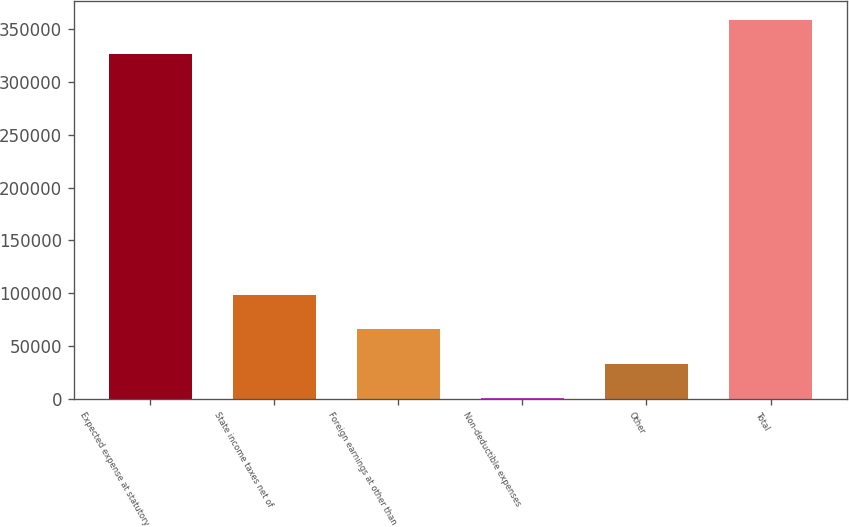Convert chart to OTSL. <chart><loc_0><loc_0><loc_500><loc_500><bar_chart><fcel>Expected expense at statutory<fcel>State income taxes net of<fcel>Foreign earnings at other than<fcel>Non-deductible expenses<fcel>Other<fcel>Total<nl><fcel>326087<fcel>98379.8<fcel>65827.2<fcel>722<fcel>33274.6<fcel>358640<nl></chart> 